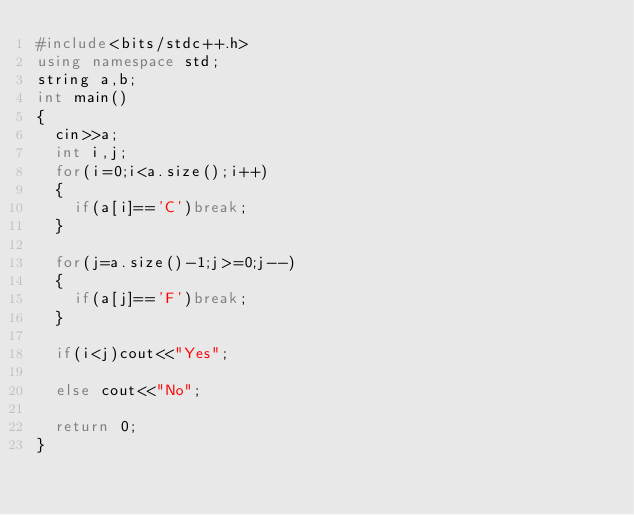<code> <loc_0><loc_0><loc_500><loc_500><_C++_>#include<bits/stdc++.h>
using namespace std;
string a,b;
int main()
{
	cin>>a;
	int i,j;
	for(i=0;i<a.size();i++)
	{
		if(a[i]=='C')break;
	}
	
	for(j=a.size()-1;j>=0;j--)
	{
		if(a[j]=='F')break;
	}
	
	if(i<j)cout<<"Yes";
	
	else cout<<"No";
	
	return 0;
}</code> 